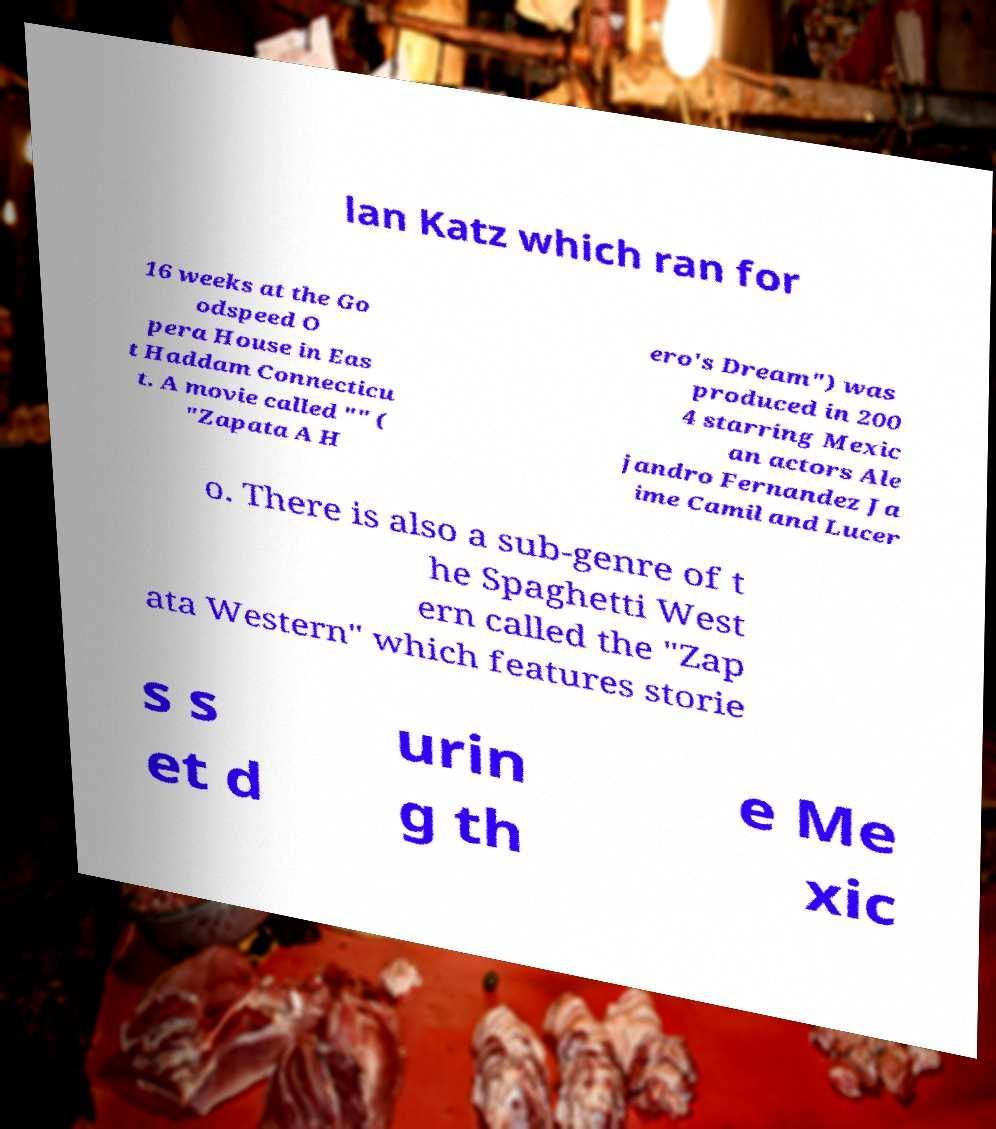I need the written content from this picture converted into text. Can you do that? lan Katz which ran for 16 weeks at the Go odspeed O pera House in Eas t Haddam Connecticu t. A movie called "" ( "Zapata A H ero's Dream") was produced in 200 4 starring Mexic an actors Ale jandro Fernandez Ja ime Camil and Lucer o. There is also a sub-genre of t he Spaghetti West ern called the "Zap ata Western" which features storie s s et d urin g th e Me xic 